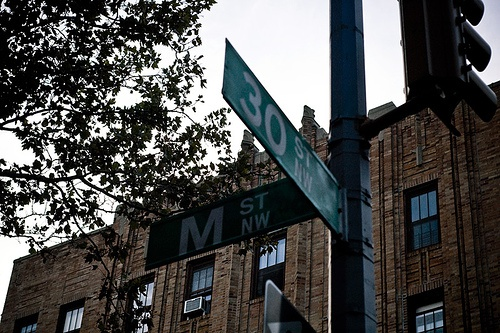Describe the objects in this image and their specific colors. I can see a traffic light in black, gray, and darkgray tones in this image. 